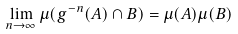<formula> <loc_0><loc_0><loc_500><loc_500>\lim _ { n \to \infty } \mu ( g ^ { - n } ( A ) \cap B ) = \mu ( A ) \mu ( B )</formula> 